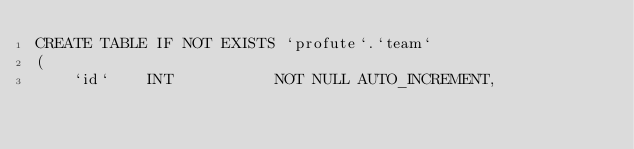Convert code to text. <code><loc_0><loc_0><loc_500><loc_500><_SQL_>CREATE TABLE IF NOT EXISTS `profute`.`team`
(
    `id`    INT           NOT NULL AUTO_INCREMENT,</code> 